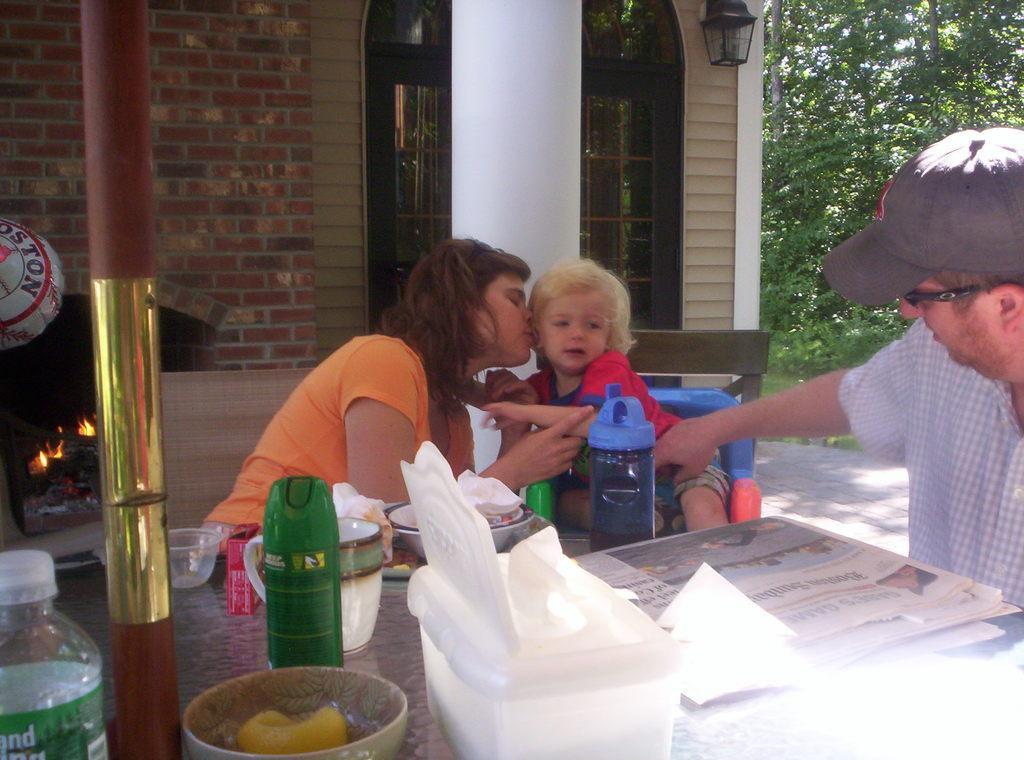Could you give a brief overview of what you see in this image? This image is clicked outside the house. In this image there are three people. To the left, there is a fireplace. In the front, there is a table, on which bottle, bowl, box are kept. To the right, there is a man wearing a cap. In the middle, there is a woman and a kid. In the background, there is a building with bricks wall and pillar. 